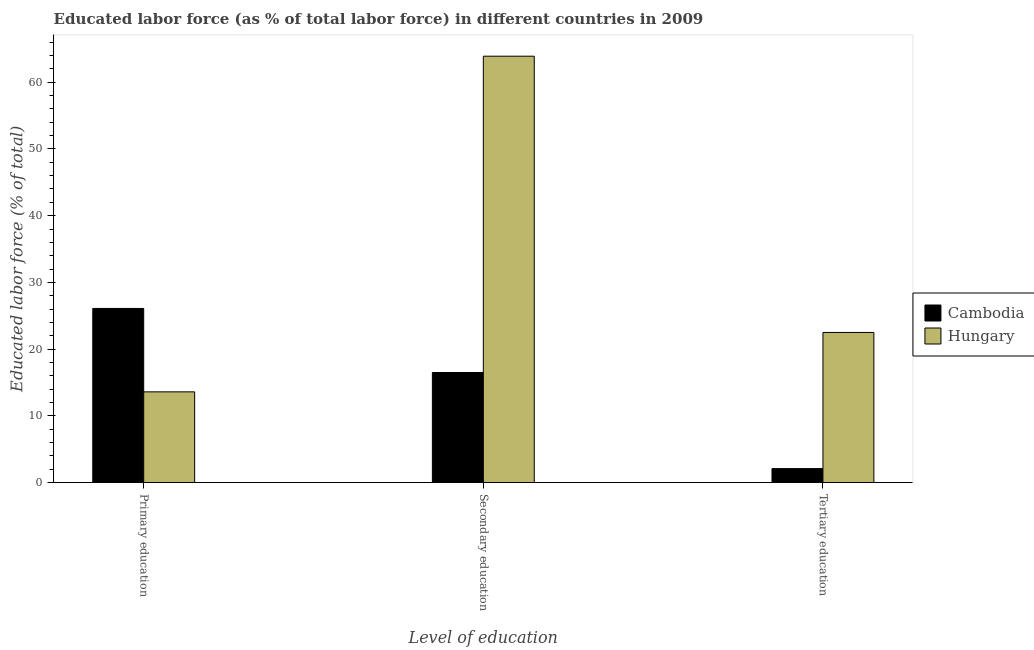How many groups of bars are there?
Offer a terse response. 3. Are the number of bars per tick equal to the number of legend labels?
Offer a very short reply. Yes. Are the number of bars on each tick of the X-axis equal?
Offer a very short reply. Yes. How many bars are there on the 3rd tick from the left?
Make the answer very short. 2. What is the label of the 1st group of bars from the left?
Provide a succinct answer. Primary education. What is the percentage of labor force who received tertiary education in Cambodia?
Your answer should be very brief. 2.1. Across all countries, what is the minimum percentage of labor force who received tertiary education?
Give a very brief answer. 2.1. In which country was the percentage of labor force who received secondary education maximum?
Offer a very short reply. Hungary. In which country was the percentage of labor force who received secondary education minimum?
Provide a succinct answer. Cambodia. What is the total percentage of labor force who received tertiary education in the graph?
Provide a succinct answer. 24.6. What is the difference between the percentage of labor force who received primary education in Hungary and that in Cambodia?
Your response must be concise. -12.5. What is the difference between the percentage of labor force who received secondary education in Hungary and the percentage of labor force who received primary education in Cambodia?
Give a very brief answer. 37.8. What is the average percentage of labor force who received primary education per country?
Offer a very short reply. 19.85. What is the difference between the percentage of labor force who received secondary education and percentage of labor force who received tertiary education in Hungary?
Make the answer very short. 41.4. What is the ratio of the percentage of labor force who received primary education in Cambodia to that in Hungary?
Your response must be concise. 1.92. What is the difference between the highest and the second highest percentage of labor force who received secondary education?
Offer a very short reply. 47.4. What is the difference between the highest and the lowest percentage of labor force who received tertiary education?
Your response must be concise. 20.4. Is the sum of the percentage of labor force who received secondary education in Hungary and Cambodia greater than the maximum percentage of labor force who received primary education across all countries?
Offer a very short reply. Yes. What does the 2nd bar from the left in Primary education represents?
Ensure brevity in your answer.  Hungary. What does the 1st bar from the right in Primary education represents?
Give a very brief answer. Hungary. Is it the case that in every country, the sum of the percentage of labor force who received primary education and percentage of labor force who received secondary education is greater than the percentage of labor force who received tertiary education?
Your response must be concise. Yes. How many bars are there?
Provide a succinct answer. 6. What is the difference between two consecutive major ticks on the Y-axis?
Keep it short and to the point. 10. Are the values on the major ticks of Y-axis written in scientific E-notation?
Your response must be concise. No. Does the graph contain any zero values?
Give a very brief answer. No. Does the graph contain grids?
Make the answer very short. No. Where does the legend appear in the graph?
Provide a succinct answer. Center right. How many legend labels are there?
Make the answer very short. 2. What is the title of the graph?
Your response must be concise. Educated labor force (as % of total labor force) in different countries in 2009. Does "Jamaica" appear as one of the legend labels in the graph?
Your answer should be very brief. No. What is the label or title of the X-axis?
Your response must be concise. Level of education. What is the label or title of the Y-axis?
Provide a short and direct response. Educated labor force (% of total). What is the Educated labor force (% of total) of Cambodia in Primary education?
Your response must be concise. 26.1. What is the Educated labor force (% of total) in Hungary in Primary education?
Make the answer very short. 13.6. What is the Educated labor force (% of total) in Hungary in Secondary education?
Provide a short and direct response. 63.9. What is the Educated labor force (% of total) in Cambodia in Tertiary education?
Offer a terse response. 2.1. Across all Level of education, what is the maximum Educated labor force (% of total) in Cambodia?
Ensure brevity in your answer.  26.1. Across all Level of education, what is the maximum Educated labor force (% of total) of Hungary?
Ensure brevity in your answer.  63.9. Across all Level of education, what is the minimum Educated labor force (% of total) of Cambodia?
Offer a very short reply. 2.1. Across all Level of education, what is the minimum Educated labor force (% of total) in Hungary?
Ensure brevity in your answer.  13.6. What is the total Educated labor force (% of total) in Cambodia in the graph?
Your answer should be very brief. 44.7. What is the difference between the Educated labor force (% of total) in Cambodia in Primary education and that in Secondary education?
Offer a very short reply. 9.6. What is the difference between the Educated labor force (% of total) of Hungary in Primary education and that in Secondary education?
Your response must be concise. -50.3. What is the difference between the Educated labor force (% of total) of Cambodia in Secondary education and that in Tertiary education?
Keep it short and to the point. 14.4. What is the difference between the Educated labor force (% of total) of Hungary in Secondary education and that in Tertiary education?
Offer a terse response. 41.4. What is the difference between the Educated labor force (% of total) of Cambodia in Primary education and the Educated labor force (% of total) of Hungary in Secondary education?
Provide a short and direct response. -37.8. What is the difference between the Educated labor force (% of total) of Cambodia in Primary education and the Educated labor force (% of total) of Hungary in Tertiary education?
Keep it short and to the point. 3.6. What is the difference between the Educated labor force (% of total) in Cambodia in Secondary education and the Educated labor force (% of total) in Hungary in Tertiary education?
Your answer should be compact. -6. What is the average Educated labor force (% of total) of Hungary per Level of education?
Provide a short and direct response. 33.33. What is the difference between the Educated labor force (% of total) in Cambodia and Educated labor force (% of total) in Hungary in Primary education?
Give a very brief answer. 12.5. What is the difference between the Educated labor force (% of total) of Cambodia and Educated labor force (% of total) of Hungary in Secondary education?
Provide a succinct answer. -47.4. What is the difference between the Educated labor force (% of total) in Cambodia and Educated labor force (% of total) in Hungary in Tertiary education?
Offer a terse response. -20.4. What is the ratio of the Educated labor force (% of total) of Cambodia in Primary education to that in Secondary education?
Your response must be concise. 1.58. What is the ratio of the Educated labor force (% of total) in Hungary in Primary education to that in Secondary education?
Make the answer very short. 0.21. What is the ratio of the Educated labor force (% of total) in Cambodia in Primary education to that in Tertiary education?
Provide a short and direct response. 12.43. What is the ratio of the Educated labor force (% of total) of Hungary in Primary education to that in Tertiary education?
Offer a terse response. 0.6. What is the ratio of the Educated labor force (% of total) in Cambodia in Secondary education to that in Tertiary education?
Give a very brief answer. 7.86. What is the ratio of the Educated labor force (% of total) in Hungary in Secondary education to that in Tertiary education?
Ensure brevity in your answer.  2.84. What is the difference between the highest and the second highest Educated labor force (% of total) of Cambodia?
Make the answer very short. 9.6. What is the difference between the highest and the second highest Educated labor force (% of total) in Hungary?
Keep it short and to the point. 41.4. What is the difference between the highest and the lowest Educated labor force (% of total) in Hungary?
Offer a very short reply. 50.3. 